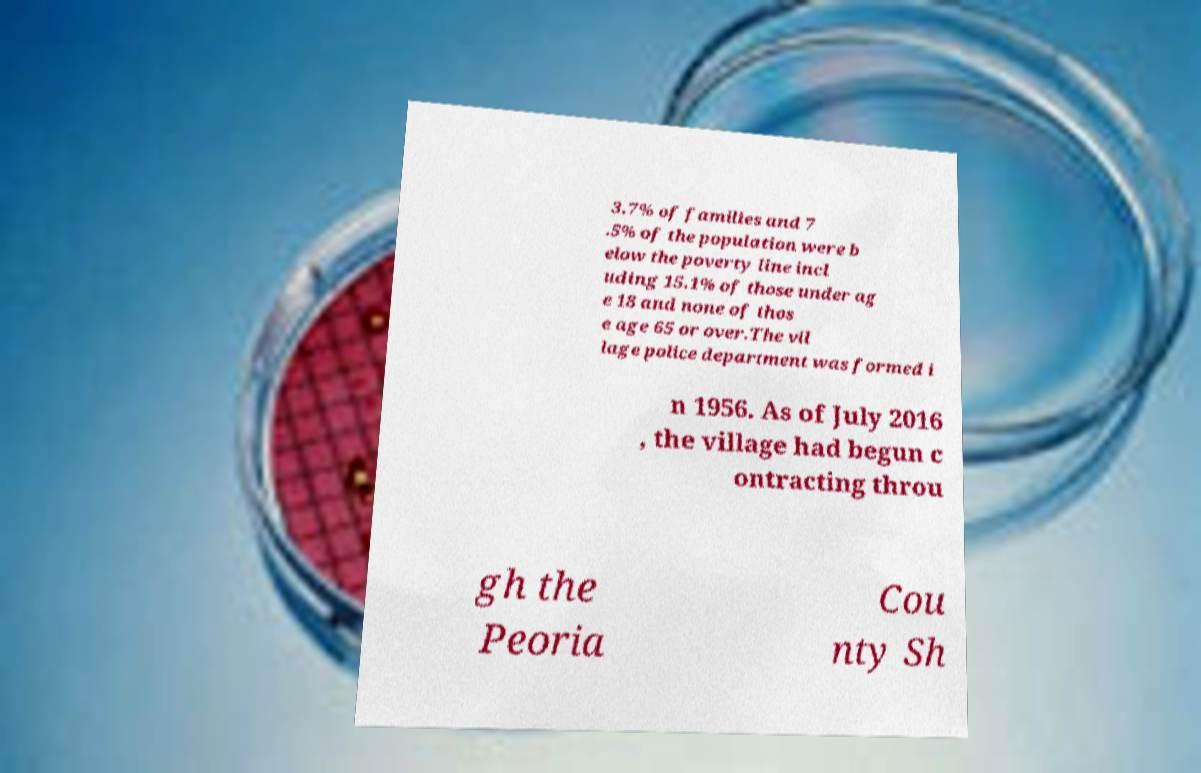Can you accurately transcribe the text from the provided image for me? 3.7% of families and 7 .5% of the population were b elow the poverty line incl uding 15.1% of those under ag e 18 and none of thos e age 65 or over.The vil lage police department was formed i n 1956. As of July 2016 , the village had begun c ontracting throu gh the Peoria Cou nty Sh 